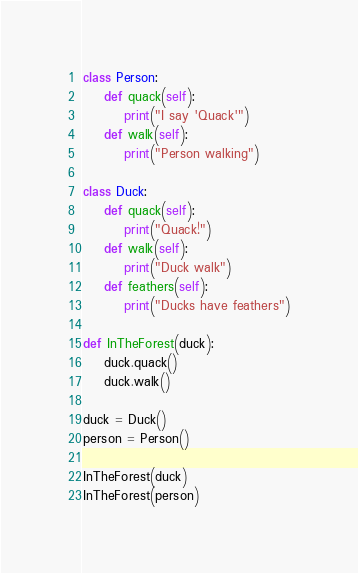Convert code to text. <code><loc_0><loc_0><loc_500><loc_500><_Python_>class Person:
    def quack(self):
        print("I say 'Quack'")
    def walk(self):
        print("Person walking")

class Duck:
    def quack(self):
        print("Quack!")
    def walk(self):
        print("Duck walk")
    def feathers(self):
        print("Ducks have feathers")

def InTheForest(duck):
    duck.quack()
    duck.walk()

duck = Duck()
person = Person()

InTheForest(duck)
InTheForest(person)
</code> 